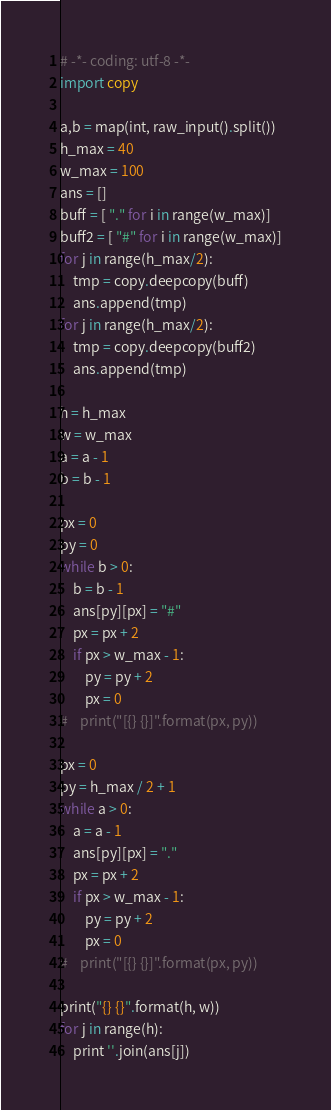Convert code to text. <code><loc_0><loc_0><loc_500><loc_500><_Python_># -*- coding: utf-8 -*-
import copy

a,b = map(int, raw_input().split())
h_max = 40
w_max = 100
ans = []
buff = [ "." for i in range(w_max)]
buff2 = [ "#" for i in range(w_max)]
for j in range(h_max/2):
    tmp = copy.deepcopy(buff)
    ans.append(tmp)
for j in range(h_max/2):
    tmp = copy.deepcopy(buff2)
    ans.append(tmp)

h = h_max
w = w_max
a = a - 1
b = b - 1

px = 0
py = 0
while b > 0:
    b = b - 1
    ans[py][px] = "#"
    px = px + 2
    if px > w_max - 1:
        py = py + 2
        px = 0
#    print("[{} {}]".format(px, py))

px = 0
py = h_max / 2 + 1
while a > 0:
    a = a - 1
    ans[py][px] = "."
    px = px + 2
    if px > w_max - 1:
        py = py + 2
        px = 0
#    print("[{} {}]".format(px, py))

print("{} {}".format(h, w))
for j in range(h):
    print ''.join(ans[j])

</code> 